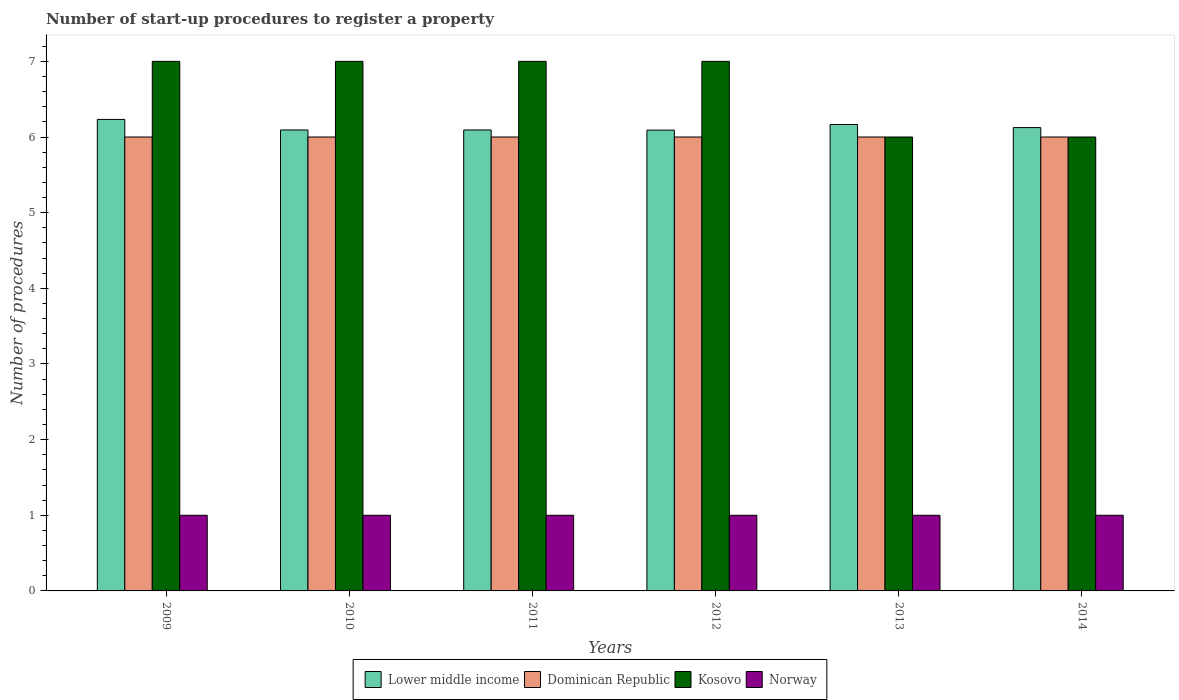How many different coloured bars are there?
Your answer should be compact. 4. Are the number of bars per tick equal to the number of legend labels?
Your response must be concise. Yes. What is the label of the 3rd group of bars from the left?
Make the answer very short. 2011. What is the number of procedures required to register a property in Lower middle income in 2013?
Your response must be concise. 6.17. Across all years, what is the maximum number of procedures required to register a property in Norway?
Offer a terse response. 1. Across all years, what is the minimum number of procedures required to register a property in Dominican Republic?
Keep it short and to the point. 6. In which year was the number of procedures required to register a property in Kosovo maximum?
Keep it short and to the point. 2009. What is the total number of procedures required to register a property in Dominican Republic in the graph?
Make the answer very short. 36. What is the difference between the number of procedures required to register a property in Kosovo in 2011 and the number of procedures required to register a property in Norway in 2009?
Your response must be concise. 6. In how many years, is the number of procedures required to register a property in Dominican Republic greater than 0.6000000000000001?
Provide a succinct answer. 6. What is the difference between the highest and the second highest number of procedures required to register a property in Dominican Republic?
Provide a short and direct response. 0. What is the difference between the highest and the lowest number of procedures required to register a property in Lower middle income?
Keep it short and to the point. 0.14. In how many years, is the number of procedures required to register a property in Dominican Republic greater than the average number of procedures required to register a property in Dominican Republic taken over all years?
Provide a short and direct response. 0. Is the sum of the number of procedures required to register a property in Kosovo in 2010 and 2013 greater than the maximum number of procedures required to register a property in Norway across all years?
Offer a terse response. Yes. Is it the case that in every year, the sum of the number of procedures required to register a property in Kosovo and number of procedures required to register a property in Norway is greater than the sum of number of procedures required to register a property in Lower middle income and number of procedures required to register a property in Dominican Republic?
Your answer should be compact. No. What does the 2nd bar from the left in 2014 represents?
Offer a very short reply. Dominican Republic. What does the 1st bar from the right in 2010 represents?
Provide a short and direct response. Norway. Is it the case that in every year, the sum of the number of procedures required to register a property in Lower middle income and number of procedures required to register a property in Norway is greater than the number of procedures required to register a property in Dominican Republic?
Give a very brief answer. Yes. How many bars are there?
Your answer should be very brief. 24. How many years are there in the graph?
Your response must be concise. 6. Does the graph contain any zero values?
Give a very brief answer. No. Does the graph contain grids?
Give a very brief answer. No. What is the title of the graph?
Make the answer very short. Number of start-up procedures to register a property. What is the label or title of the X-axis?
Your response must be concise. Years. What is the label or title of the Y-axis?
Give a very brief answer. Number of procedures. What is the Number of procedures of Lower middle income in 2009?
Your answer should be very brief. 6.23. What is the Number of procedures in Norway in 2009?
Make the answer very short. 1. What is the Number of procedures in Lower middle income in 2010?
Make the answer very short. 6.09. What is the Number of procedures of Norway in 2010?
Provide a succinct answer. 1. What is the Number of procedures in Lower middle income in 2011?
Your answer should be very brief. 6.09. What is the Number of procedures in Norway in 2011?
Provide a short and direct response. 1. What is the Number of procedures in Lower middle income in 2012?
Ensure brevity in your answer.  6.09. What is the Number of procedures of Dominican Republic in 2012?
Your answer should be very brief. 6. What is the Number of procedures in Kosovo in 2012?
Ensure brevity in your answer.  7. What is the Number of procedures of Lower middle income in 2013?
Ensure brevity in your answer.  6.17. What is the Number of procedures in Dominican Republic in 2013?
Ensure brevity in your answer.  6. What is the Number of procedures of Kosovo in 2013?
Your response must be concise. 6. What is the Number of procedures of Norway in 2013?
Ensure brevity in your answer.  1. What is the Number of procedures of Lower middle income in 2014?
Make the answer very short. 6.12. What is the Number of procedures of Norway in 2014?
Keep it short and to the point. 1. Across all years, what is the maximum Number of procedures of Lower middle income?
Your answer should be compact. 6.23. Across all years, what is the maximum Number of procedures in Kosovo?
Ensure brevity in your answer.  7. Across all years, what is the maximum Number of procedures of Norway?
Your answer should be compact. 1. Across all years, what is the minimum Number of procedures of Lower middle income?
Your answer should be compact. 6.09. Across all years, what is the minimum Number of procedures in Dominican Republic?
Make the answer very short. 6. Across all years, what is the minimum Number of procedures of Kosovo?
Your answer should be compact. 6. What is the total Number of procedures in Lower middle income in the graph?
Offer a very short reply. 36.8. What is the total Number of procedures of Kosovo in the graph?
Offer a very short reply. 40. What is the difference between the Number of procedures in Lower middle income in 2009 and that in 2010?
Offer a terse response. 0.14. What is the difference between the Number of procedures of Dominican Republic in 2009 and that in 2010?
Your answer should be compact. 0. What is the difference between the Number of procedures in Kosovo in 2009 and that in 2010?
Give a very brief answer. 0. What is the difference between the Number of procedures of Norway in 2009 and that in 2010?
Offer a very short reply. 0. What is the difference between the Number of procedures of Lower middle income in 2009 and that in 2011?
Provide a succinct answer. 0.14. What is the difference between the Number of procedures of Kosovo in 2009 and that in 2011?
Make the answer very short. 0. What is the difference between the Number of procedures in Lower middle income in 2009 and that in 2012?
Your answer should be compact. 0.14. What is the difference between the Number of procedures of Kosovo in 2009 and that in 2012?
Your response must be concise. 0. What is the difference between the Number of procedures of Lower middle income in 2009 and that in 2013?
Your response must be concise. 0.07. What is the difference between the Number of procedures of Kosovo in 2009 and that in 2013?
Your answer should be compact. 1. What is the difference between the Number of procedures in Lower middle income in 2009 and that in 2014?
Your answer should be compact. 0.11. What is the difference between the Number of procedures of Dominican Republic in 2009 and that in 2014?
Make the answer very short. 0. What is the difference between the Number of procedures of Kosovo in 2010 and that in 2011?
Your answer should be very brief. 0. What is the difference between the Number of procedures in Norway in 2010 and that in 2011?
Your answer should be compact. 0. What is the difference between the Number of procedures in Lower middle income in 2010 and that in 2012?
Your response must be concise. 0. What is the difference between the Number of procedures in Dominican Republic in 2010 and that in 2012?
Make the answer very short. 0. What is the difference between the Number of procedures in Lower middle income in 2010 and that in 2013?
Make the answer very short. -0.07. What is the difference between the Number of procedures in Kosovo in 2010 and that in 2013?
Ensure brevity in your answer.  1. What is the difference between the Number of procedures in Lower middle income in 2010 and that in 2014?
Your response must be concise. -0.03. What is the difference between the Number of procedures of Dominican Republic in 2010 and that in 2014?
Offer a terse response. 0. What is the difference between the Number of procedures of Kosovo in 2010 and that in 2014?
Your answer should be compact. 1. What is the difference between the Number of procedures in Norway in 2010 and that in 2014?
Your answer should be compact. 0. What is the difference between the Number of procedures of Lower middle income in 2011 and that in 2012?
Offer a terse response. 0. What is the difference between the Number of procedures in Dominican Republic in 2011 and that in 2012?
Your response must be concise. 0. What is the difference between the Number of procedures in Lower middle income in 2011 and that in 2013?
Keep it short and to the point. -0.07. What is the difference between the Number of procedures of Kosovo in 2011 and that in 2013?
Make the answer very short. 1. What is the difference between the Number of procedures in Lower middle income in 2011 and that in 2014?
Offer a terse response. -0.03. What is the difference between the Number of procedures in Norway in 2011 and that in 2014?
Keep it short and to the point. 0. What is the difference between the Number of procedures in Lower middle income in 2012 and that in 2013?
Ensure brevity in your answer.  -0.07. What is the difference between the Number of procedures of Norway in 2012 and that in 2013?
Your answer should be compact. 0. What is the difference between the Number of procedures in Lower middle income in 2012 and that in 2014?
Offer a very short reply. -0.03. What is the difference between the Number of procedures in Lower middle income in 2013 and that in 2014?
Provide a short and direct response. 0.04. What is the difference between the Number of procedures in Dominican Republic in 2013 and that in 2014?
Your response must be concise. 0. What is the difference between the Number of procedures in Lower middle income in 2009 and the Number of procedures in Dominican Republic in 2010?
Offer a terse response. 0.23. What is the difference between the Number of procedures of Lower middle income in 2009 and the Number of procedures of Kosovo in 2010?
Provide a succinct answer. -0.77. What is the difference between the Number of procedures of Lower middle income in 2009 and the Number of procedures of Norway in 2010?
Provide a succinct answer. 5.23. What is the difference between the Number of procedures of Dominican Republic in 2009 and the Number of procedures of Kosovo in 2010?
Give a very brief answer. -1. What is the difference between the Number of procedures in Kosovo in 2009 and the Number of procedures in Norway in 2010?
Ensure brevity in your answer.  6. What is the difference between the Number of procedures in Lower middle income in 2009 and the Number of procedures in Dominican Republic in 2011?
Your response must be concise. 0.23. What is the difference between the Number of procedures in Lower middle income in 2009 and the Number of procedures in Kosovo in 2011?
Your answer should be compact. -0.77. What is the difference between the Number of procedures of Lower middle income in 2009 and the Number of procedures of Norway in 2011?
Offer a terse response. 5.23. What is the difference between the Number of procedures of Dominican Republic in 2009 and the Number of procedures of Kosovo in 2011?
Give a very brief answer. -1. What is the difference between the Number of procedures of Lower middle income in 2009 and the Number of procedures of Dominican Republic in 2012?
Provide a succinct answer. 0.23. What is the difference between the Number of procedures in Lower middle income in 2009 and the Number of procedures in Kosovo in 2012?
Provide a succinct answer. -0.77. What is the difference between the Number of procedures of Lower middle income in 2009 and the Number of procedures of Norway in 2012?
Offer a terse response. 5.23. What is the difference between the Number of procedures of Dominican Republic in 2009 and the Number of procedures of Kosovo in 2012?
Provide a short and direct response. -1. What is the difference between the Number of procedures of Lower middle income in 2009 and the Number of procedures of Dominican Republic in 2013?
Give a very brief answer. 0.23. What is the difference between the Number of procedures of Lower middle income in 2009 and the Number of procedures of Kosovo in 2013?
Your answer should be very brief. 0.23. What is the difference between the Number of procedures in Lower middle income in 2009 and the Number of procedures in Norway in 2013?
Provide a succinct answer. 5.23. What is the difference between the Number of procedures of Dominican Republic in 2009 and the Number of procedures of Kosovo in 2013?
Your response must be concise. 0. What is the difference between the Number of procedures in Kosovo in 2009 and the Number of procedures in Norway in 2013?
Your answer should be compact. 6. What is the difference between the Number of procedures of Lower middle income in 2009 and the Number of procedures of Dominican Republic in 2014?
Your answer should be compact. 0.23. What is the difference between the Number of procedures of Lower middle income in 2009 and the Number of procedures of Kosovo in 2014?
Your response must be concise. 0.23. What is the difference between the Number of procedures of Lower middle income in 2009 and the Number of procedures of Norway in 2014?
Your answer should be compact. 5.23. What is the difference between the Number of procedures in Lower middle income in 2010 and the Number of procedures in Dominican Republic in 2011?
Make the answer very short. 0.09. What is the difference between the Number of procedures in Lower middle income in 2010 and the Number of procedures in Kosovo in 2011?
Keep it short and to the point. -0.91. What is the difference between the Number of procedures in Lower middle income in 2010 and the Number of procedures in Norway in 2011?
Make the answer very short. 5.09. What is the difference between the Number of procedures in Dominican Republic in 2010 and the Number of procedures in Kosovo in 2011?
Offer a terse response. -1. What is the difference between the Number of procedures of Dominican Republic in 2010 and the Number of procedures of Norway in 2011?
Provide a succinct answer. 5. What is the difference between the Number of procedures of Kosovo in 2010 and the Number of procedures of Norway in 2011?
Your response must be concise. 6. What is the difference between the Number of procedures of Lower middle income in 2010 and the Number of procedures of Dominican Republic in 2012?
Your answer should be compact. 0.09. What is the difference between the Number of procedures of Lower middle income in 2010 and the Number of procedures of Kosovo in 2012?
Your answer should be compact. -0.91. What is the difference between the Number of procedures in Lower middle income in 2010 and the Number of procedures in Norway in 2012?
Ensure brevity in your answer.  5.09. What is the difference between the Number of procedures of Dominican Republic in 2010 and the Number of procedures of Kosovo in 2012?
Provide a short and direct response. -1. What is the difference between the Number of procedures in Dominican Republic in 2010 and the Number of procedures in Norway in 2012?
Your answer should be compact. 5. What is the difference between the Number of procedures of Kosovo in 2010 and the Number of procedures of Norway in 2012?
Offer a terse response. 6. What is the difference between the Number of procedures in Lower middle income in 2010 and the Number of procedures in Dominican Republic in 2013?
Provide a short and direct response. 0.09. What is the difference between the Number of procedures of Lower middle income in 2010 and the Number of procedures of Kosovo in 2013?
Your answer should be compact. 0.09. What is the difference between the Number of procedures of Lower middle income in 2010 and the Number of procedures of Norway in 2013?
Your answer should be very brief. 5.09. What is the difference between the Number of procedures of Dominican Republic in 2010 and the Number of procedures of Kosovo in 2013?
Provide a short and direct response. 0. What is the difference between the Number of procedures in Dominican Republic in 2010 and the Number of procedures in Norway in 2013?
Give a very brief answer. 5. What is the difference between the Number of procedures of Kosovo in 2010 and the Number of procedures of Norway in 2013?
Provide a short and direct response. 6. What is the difference between the Number of procedures of Lower middle income in 2010 and the Number of procedures of Dominican Republic in 2014?
Give a very brief answer. 0.09. What is the difference between the Number of procedures in Lower middle income in 2010 and the Number of procedures in Kosovo in 2014?
Provide a short and direct response. 0.09. What is the difference between the Number of procedures of Lower middle income in 2010 and the Number of procedures of Norway in 2014?
Offer a terse response. 5.09. What is the difference between the Number of procedures in Dominican Republic in 2010 and the Number of procedures in Norway in 2014?
Offer a terse response. 5. What is the difference between the Number of procedures in Kosovo in 2010 and the Number of procedures in Norway in 2014?
Your answer should be compact. 6. What is the difference between the Number of procedures in Lower middle income in 2011 and the Number of procedures in Dominican Republic in 2012?
Provide a succinct answer. 0.09. What is the difference between the Number of procedures of Lower middle income in 2011 and the Number of procedures of Kosovo in 2012?
Make the answer very short. -0.91. What is the difference between the Number of procedures of Lower middle income in 2011 and the Number of procedures of Norway in 2012?
Ensure brevity in your answer.  5.09. What is the difference between the Number of procedures in Kosovo in 2011 and the Number of procedures in Norway in 2012?
Offer a terse response. 6. What is the difference between the Number of procedures of Lower middle income in 2011 and the Number of procedures of Dominican Republic in 2013?
Offer a terse response. 0.09. What is the difference between the Number of procedures of Lower middle income in 2011 and the Number of procedures of Kosovo in 2013?
Make the answer very short. 0.09. What is the difference between the Number of procedures in Lower middle income in 2011 and the Number of procedures in Norway in 2013?
Your answer should be compact. 5.09. What is the difference between the Number of procedures in Lower middle income in 2011 and the Number of procedures in Dominican Republic in 2014?
Ensure brevity in your answer.  0.09. What is the difference between the Number of procedures in Lower middle income in 2011 and the Number of procedures in Kosovo in 2014?
Give a very brief answer. 0.09. What is the difference between the Number of procedures in Lower middle income in 2011 and the Number of procedures in Norway in 2014?
Offer a very short reply. 5.09. What is the difference between the Number of procedures of Dominican Republic in 2011 and the Number of procedures of Norway in 2014?
Keep it short and to the point. 5. What is the difference between the Number of procedures of Kosovo in 2011 and the Number of procedures of Norway in 2014?
Provide a succinct answer. 6. What is the difference between the Number of procedures in Lower middle income in 2012 and the Number of procedures in Dominican Republic in 2013?
Offer a terse response. 0.09. What is the difference between the Number of procedures in Lower middle income in 2012 and the Number of procedures in Kosovo in 2013?
Your response must be concise. 0.09. What is the difference between the Number of procedures of Lower middle income in 2012 and the Number of procedures of Norway in 2013?
Ensure brevity in your answer.  5.09. What is the difference between the Number of procedures of Dominican Republic in 2012 and the Number of procedures of Kosovo in 2013?
Ensure brevity in your answer.  0. What is the difference between the Number of procedures in Lower middle income in 2012 and the Number of procedures in Dominican Republic in 2014?
Offer a very short reply. 0.09. What is the difference between the Number of procedures of Lower middle income in 2012 and the Number of procedures of Kosovo in 2014?
Provide a short and direct response. 0.09. What is the difference between the Number of procedures of Lower middle income in 2012 and the Number of procedures of Norway in 2014?
Keep it short and to the point. 5.09. What is the difference between the Number of procedures of Dominican Republic in 2012 and the Number of procedures of Kosovo in 2014?
Provide a short and direct response. 0. What is the difference between the Number of procedures in Kosovo in 2012 and the Number of procedures in Norway in 2014?
Provide a succinct answer. 6. What is the difference between the Number of procedures of Lower middle income in 2013 and the Number of procedures of Dominican Republic in 2014?
Provide a succinct answer. 0.17. What is the difference between the Number of procedures of Lower middle income in 2013 and the Number of procedures of Kosovo in 2014?
Provide a short and direct response. 0.17. What is the difference between the Number of procedures of Lower middle income in 2013 and the Number of procedures of Norway in 2014?
Give a very brief answer. 5.17. What is the difference between the Number of procedures in Dominican Republic in 2013 and the Number of procedures in Norway in 2014?
Make the answer very short. 5. What is the difference between the Number of procedures in Kosovo in 2013 and the Number of procedures in Norway in 2014?
Your answer should be very brief. 5. What is the average Number of procedures in Lower middle income per year?
Offer a very short reply. 6.13. What is the average Number of procedures of Dominican Republic per year?
Keep it short and to the point. 6. What is the average Number of procedures of Kosovo per year?
Offer a terse response. 6.67. In the year 2009, what is the difference between the Number of procedures in Lower middle income and Number of procedures in Dominican Republic?
Offer a terse response. 0.23. In the year 2009, what is the difference between the Number of procedures in Lower middle income and Number of procedures in Kosovo?
Keep it short and to the point. -0.77. In the year 2009, what is the difference between the Number of procedures of Lower middle income and Number of procedures of Norway?
Make the answer very short. 5.23. In the year 2009, what is the difference between the Number of procedures in Dominican Republic and Number of procedures in Kosovo?
Give a very brief answer. -1. In the year 2010, what is the difference between the Number of procedures of Lower middle income and Number of procedures of Dominican Republic?
Provide a short and direct response. 0.09. In the year 2010, what is the difference between the Number of procedures in Lower middle income and Number of procedures in Kosovo?
Offer a terse response. -0.91. In the year 2010, what is the difference between the Number of procedures of Lower middle income and Number of procedures of Norway?
Offer a very short reply. 5.09. In the year 2010, what is the difference between the Number of procedures of Dominican Republic and Number of procedures of Kosovo?
Offer a very short reply. -1. In the year 2010, what is the difference between the Number of procedures in Dominican Republic and Number of procedures in Norway?
Your response must be concise. 5. In the year 2011, what is the difference between the Number of procedures of Lower middle income and Number of procedures of Dominican Republic?
Ensure brevity in your answer.  0.09. In the year 2011, what is the difference between the Number of procedures of Lower middle income and Number of procedures of Kosovo?
Provide a succinct answer. -0.91. In the year 2011, what is the difference between the Number of procedures in Lower middle income and Number of procedures in Norway?
Make the answer very short. 5.09. In the year 2011, what is the difference between the Number of procedures of Dominican Republic and Number of procedures of Kosovo?
Offer a very short reply. -1. In the year 2011, what is the difference between the Number of procedures of Dominican Republic and Number of procedures of Norway?
Keep it short and to the point. 5. In the year 2011, what is the difference between the Number of procedures in Kosovo and Number of procedures in Norway?
Offer a terse response. 6. In the year 2012, what is the difference between the Number of procedures of Lower middle income and Number of procedures of Dominican Republic?
Offer a terse response. 0.09. In the year 2012, what is the difference between the Number of procedures in Lower middle income and Number of procedures in Kosovo?
Ensure brevity in your answer.  -0.91. In the year 2012, what is the difference between the Number of procedures of Lower middle income and Number of procedures of Norway?
Ensure brevity in your answer.  5.09. In the year 2012, what is the difference between the Number of procedures in Kosovo and Number of procedures in Norway?
Ensure brevity in your answer.  6. In the year 2013, what is the difference between the Number of procedures of Lower middle income and Number of procedures of Dominican Republic?
Provide a short and direct response. 0.17. In the year 2013, what is the difference between the Number of procedures of Lower middle income and Number of procedures of Kosovo?
Your response must be concise. 0.17. In the year 2013, what is the difference between the Number of procedures of Lower middle income and Number of procedures of Norway?
Give a very brief answer. 5.17. In the year 2013, what is the difference between the Number of procedures of Dominican Republic and Number of procedures of Kosovo?
Offer a very short reply. 0. In the year 2013, what is the difference between the Number of procedures of Dominican Republic and Number of procedures of Norway?
Offer a very short reply. 5. In the year 2013, what is the difference between the Number of procedures in Kosovo and Number of procedures in Norway?
Provide a succinct answer. 5. In the year 2014, what is the difference between the Number of procedures of Lower middle income and Number of procedures of Dominican Republic?
Your answer should be compact. 0.12. In the year 2014, what is the difference between the Number of procedures of Lower middle income and Number of procedures of Kosovo?
Keep it short and to the point. 0.12. In the year 2014, what is the difference between the Number of procedures of Lower middle income and Number of procedures of Norway?
Provide a succinct answer. 5.12. In the year 2014, what is the difference between the Number of procedures in Dominican Republic and Number of procedures in Kosovo?
Keep it short and to the point. 0. In the year 2014, what is the difference between the Number of procedures of Dominican Republic and Number of procedures of Norway?
Keep it short and to the point. 5. What is the ratio of the Number of procedures in Lower middle income in 2009 to that in 2010?
Give a very brief answer. 1.02. What is the ratio of the Number of procedures in Dominican Republic in 2009 to that in 2010?
Provide a short and direct response. 1. What is the ratio of the Number of procedures in Kosovo in 2009 to that in 2010?
Provide a succinct answer. 1. What is the ratio of the Number of procedures of Lower middle income in 2009 to that in 2011?
Offer a very short reply. 1.02. What is the ratio of the Number of procedures of Dominican Republic in 2009 to that in 2011?
Your answer should be very brief. 1. What is the ratio of the Number of procedures in Lower middle income in 2009 to that in 2012?
Keep it short and to the point. 1.02. What is the ratio of the Number of procedures in Dominican Republic in 2009 to that in 2012?
Provide a short and direct response. 1. What is the ratio of the Number of procedures of Norway in 2009 to that in 2012?
Keep it short and to the point. 1. What is the ratio of the Number of procedures in Lower middle income in 2009 to that in 2013?
Your answer should be compact. 1.01. What is the ratio of the Number of procedures in Dominican Republic in 2009 to that in 2013?
Provide a succinct answer. 1. What is the ratio of the Number of procedures of Kosovo in 2009 to that in 2013?
Ensure brevity in your answer.  1.17. What is the ratio of the Number of procedures of Norway in 2009 to that in 2013?
Make the answer very short. 1. What is the ratio of the Number of procedures of Lower middle income in 2009 to that in 2014?
Offer a very short reply. 1.02. What is the ratio of the Number of procedures in Kosovo in 2009 to that in 2014?
Offer a terse response. 1.17. What is the ratio of the Number of procedures in Lower middle income in 2010 to that in 2011?
Keep it short and to the point. 1. What is the ratio of the Number of procedures in Dominican Republic in 2010 to that in 2011?
Provide a short and direct response. 1. What is the ratio of the Number of procedures of Kosovo in 2010 to that in 2011?
Ensure brevity in your answer.  1. What is the ratio of the Number of procedures of Norway in 2010 to that in 2011?
Provide a short and direct response. 1. What is the ratio of the Number of procedures in Lower middle income in 2010 to that in 2012?
Make the answer very short. 1. What is the ratio of the Number of procedures of Kosovo in 2010 to that in 2012?
Keep it short and to the point. 1. What is the ratio of the Number of procedures of Lower middle income in 2010 to that in 2013?
Provide a short and direct response. 0.99. What is the ratio of the Number of procedures in Kosovo in 2010 to that in 2013?
Your response must be concise. 1.17. What is the ratio of the Number of procedures of Dominican Republic in 2010 to that in 2014?
Offer a terse response. 1. What is the ratio of the Number of procedures of Norway in 2010 to that in 2014?
Give a very brief answer. 1. What is the ratio of the Number of procedures in Kosovo in 2011 to that in 2012?
Ensure brevity in your answer.  1. What is the ratio of the Number of procedures in Norway in 2011 to that in 2012?
Your answer should be compact. 1. What is the ratio of the Number of procedures of Lower middle income in 2011 to that in 2013?
Keep it short and to the point. 0.99. What is the ratio of the Number of procedures in Kosovo in 2011 to that in 2013?
Give a very brief answer. 1.17. What is the ratio of the Number of procedures of Norway in 2011 to that in 2013?
Keep it short and to the point. 1. What is the ratio of the Number of procedures in Dominican Republic in 2011 to that in 2014?
Provide a succinct answer. 1. What is the ratio of the Number of procedures of Kosovo in 2011 to that in 2014?
Make the answer very short. 1.17. What is the ratio of the Number of procedures in Lower middle income in 2012 to that in 2013?
Ensure brevity in your answer.  0.99. What is the ratio of the Number of procedures in Dominican Republic in 2012 to that in 2013?
Make the answer very short. 1. What is the ratio of the Number of procedures in Kosovo in 2012 to that in 2013?
Your answer should be very brief. 1.17. What is the ratio of the Number of procedures of Norway in 2012 to that in 2013?
Your answer should be very brief. 1. What is the ratio of the Number of procedures of Norway in 2012 to that in 2014?
Give a very brief answer. 1. What is the ratio of the Number of procedures of Norway in 2013 to that in 2014?
Offer a terse response. 1. What is the difference between the highest and the second highest Number of procedures of Lower middle income?
Your answer should be compact. 0.07. What is the difference between the highest and the second highest Number of procedures of Norway?
Your answer should be very brief. 0. What is the difference between the highest and the lowest Number of procedures in Lower middle income?
Provide a short and direct response. 0.14. What is the difference between the highest and the lowest Number of procedures in Dominican Republic?
Offer a terse response. 0. What is the difference between the highest and the lowest Number of procedures of Kosovo?
Your answer should be compact. 1. 